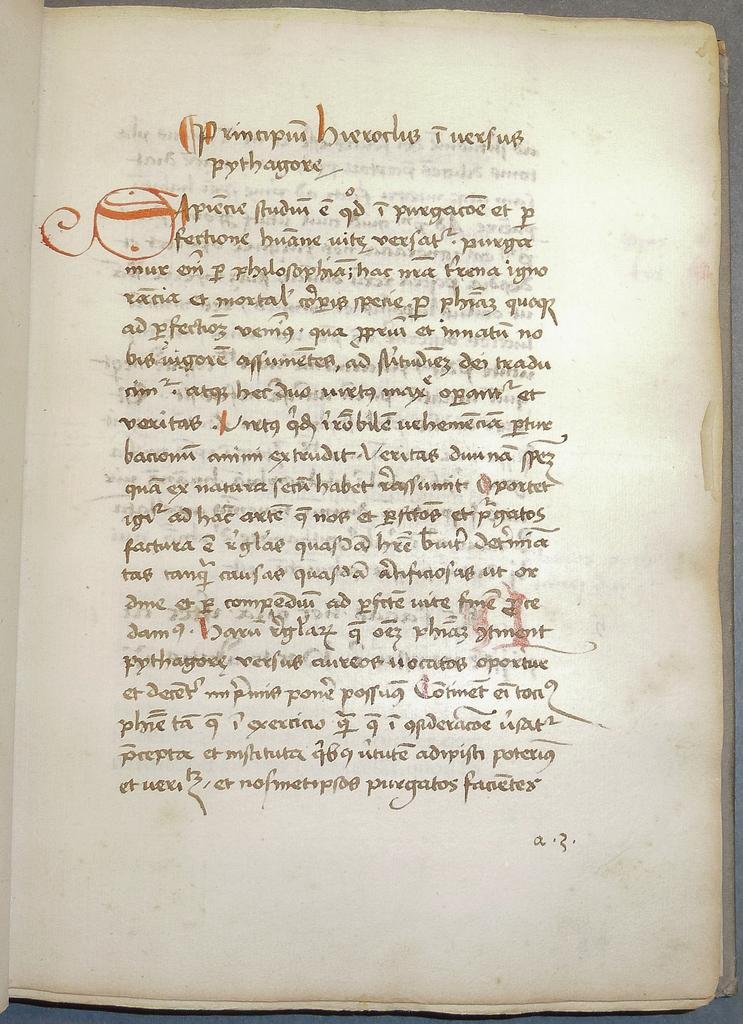Provide a one-sentence caption for the provided image. an old paper with a lot of writing in an indecipherable language. 